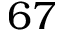Convert formula to latex. <formula><loc_0><loc_0><loc_500><loc_500>6 7</formula> 